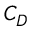<formula> <loc_0><loc_0><loc_500><loc_500>C _ { D }</formula> 